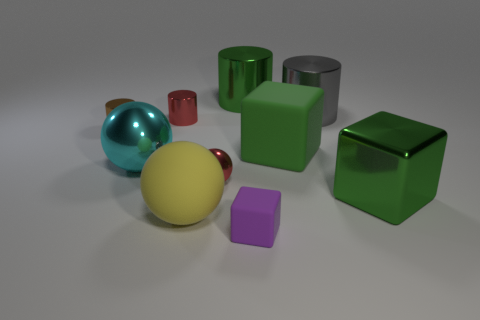There is a tiny shiny cylinder that is to the right of the brown metal cylinder; is its color the same as the shiny ball in front of the big cyan shiny sphere?
Your answer should be very brief. Yes. What is the red sphere made of?
Provide a short and direct response. Metal. How many other objects are the same shape as the yellow object?
Your response must be concise. 2. Does the purple thing have the same shape as the green matte object?
Your answer should be very brief. Yes. What number of things are tiny brown things to the left of the red shiny cylinder or big shiny things that are to the left of the tiny red metal sphere?
Offer a terse response. 2. What number of objects are either brown shiny cylinders or rubber balls?
Make the answer very short. 2. There is a large shiny cylinder left of the small purple thing; what number of metal cylinders are in front of it?
Provide a short and direct response. 3. How many other things are the same size as the green metallic block?
Give a very brief answer. 5. There is a cylinder that is the same color as the large metal cube; what size is it?
Offer a very short reply. Large. Do the small shiny object that is in front of the cyan thing and the small brown object have the same shape?
Your answer should be very brief. No. 